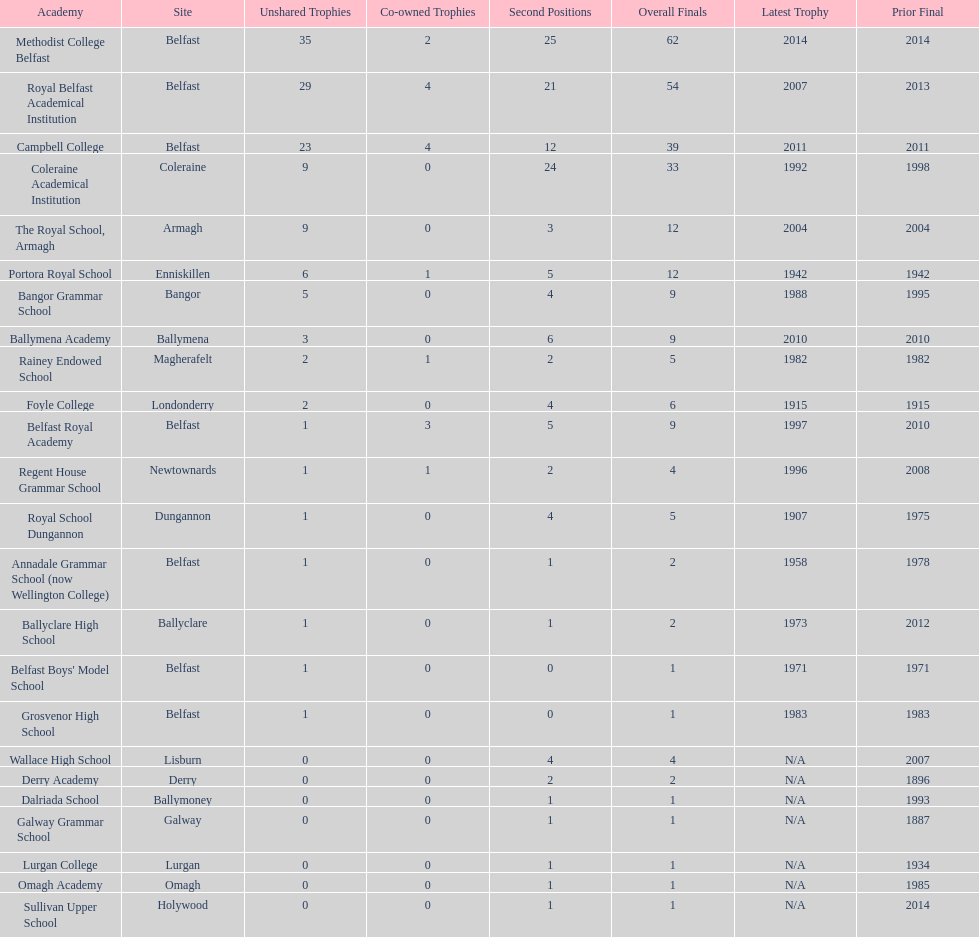Could you help me parse every detail presented in this table? {'header': ['Academy', 'Site', 'Unshared Trophies', 'Co-owned Trophies', 'Second Positions', 'Overall Finals', 'Latest Trophy', 'Prior Final'], 'rows': [['Methodist College Belfast', 'Belfast', '35', '2', '25', '62', '2014', '2014'], ['Royal Belfast Academical Institution', 'Belfast', '29', '4', '21', '54', '2007', '2013'], ['Campbell College', 'Belfast', '23', '4', '12', '39', '2011', '2011'], ['Coleraine Academical Institution', 'Coleraine', '9', '0', '24', '33', '1992', '1998'], ['The Royal School, Armagh', 'Armagh', '9', '0', '3', '12', '2004', '2004'], ['Portora Royal School', 'Enniskillen', '6', '1', '5', '12', '1942', '1942'], ['Bangor Grammar School', 'Bangor', '5', '0', '4', '9', '1988', '1995'], ['Ballymena Academy', 'Ballymena', '3', '0', '6', '9', '2010', '2010'], ['Rainey Endowed School', 'Magherafelt', '2', '1', '2', '5', '1982', '1982'], ['Foyle College', 'Londonderry', '2', '0', '4', '6', '1915', '1915'], ['Belfast Royal Academy', 'Belfast', '1', '3', '5', '9', '1997', '2010'], ['Regent House Grammar School', 'Newtownards', '1', '1', '2', '4', '1996', '2008'], ['Royal School Dungannon', 'Dungannon', '1', '0', '4', '5', '1907', '1975'], ['Annadale Grammar School (now Wellington College)', 'Belfast', '1', '0', '1', '2', '1958', '1978'], ['Ballyclare High School', 'Ballyclare', '1', '0', '1', '2', '1973', '2012'], ["Belfast Boys' Model School", 'Belfast', '1', '0', '0', '1', '1971', '1971'], ['Grosvenor High School', 'Belfast', '1', '0', '0', '1', '1983', '1983'], ['Wallace High School', 'Lisburn', '0', '0', '4', '4', 'N/A', '2007'], ['Derry Academy', 'Derry', '0', '0', '2', '2', 'N/A', '1896'], ['Dalriada School', 'Ballymoney', '0', '0', '1', '1', 'N/A', '1993'], ['Galway Grammar School', 'Galway', '0', '0', '1', '1', 'N/A', '1887'], ['Lurgan College', 'Lurgan', '0', '0', '1', '1', 'N/A', '1934'], ['Omagh Academy', 'Omagh', '0', '0', '1', '1', 'N/A', '1985'], ['Sullivan Upper School', 'Holywood', '0', '0', '1', '1', 'N/A', '2014']]} Which schools have the largest number of shared titles? Royal Belfast Academical Institution, Campbell College. 